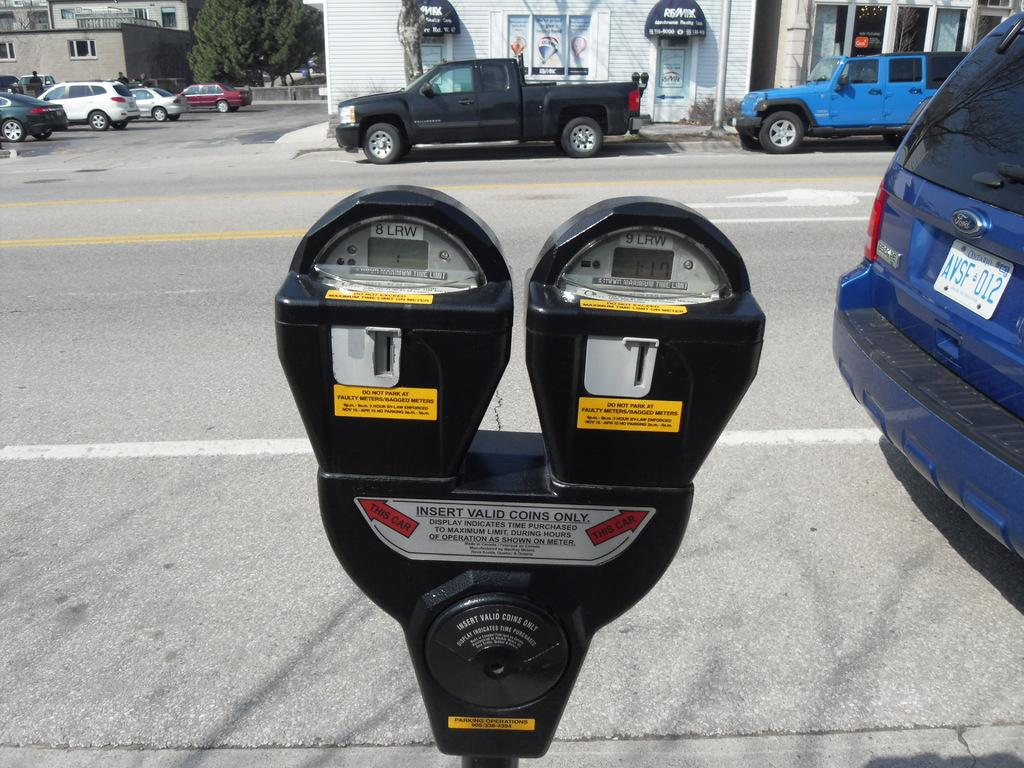<image>
Provide a brief description of the given image. Two parking meters with a sticker that says Insert valid coins only. 